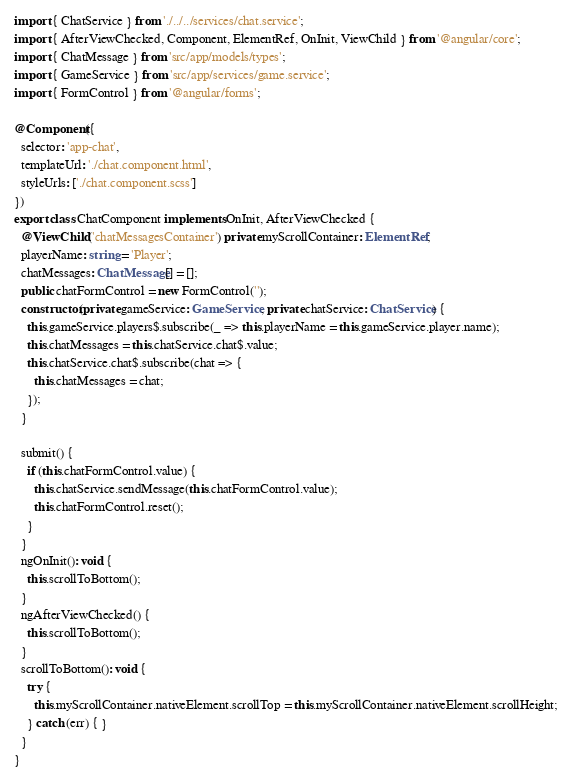Convert code to text. <code><loc_0><loc_0><loc_500><loc_500><_TypeScript_>import { ChatService } from './../../services/chat.service';
import { AfterViewChecked, Component, ElementRef, OnInit, ViewChild } from '@angular/core';
import { ChatMessage } from 'src/app/models/types';
import { GameService } from 'src/app/services/game.service';
import { FormControl } from '@angular/forms';

@Component({
  selector: 'app-chat',
  templateUrl: './chat.component.html',
  styleUrls: ['./chat.component.scss']
})
export class ChatComponent implements OnInit, AfterViewChecked {
  @ViewChild('chatMessagesContainer') private myScrollContainer: ElementRef;
  playerName: string = 'Player';
  chatMessages: ChatMessage[] = [];
  public chatFormControl = new FormControl('');
  constructor(private gameService: GameService, private chatService: ChatService) {
    this.gameService.players$.subscribe(_ => this.playerName = this.gameService.player.name);
    this.chatMessages = this.chatService.chat$.value;
    this.chatService.chat$.subscribe(chat => {
      this.chatMessages = chat;
    });
  }

  submit() {
    if (this.chatFormControl.value) {
      this.chatService.sendMessage(this.chatFormControl.value);
      this.chatFormControl.reset();
    }
  }
  ngOnInit(): void {
    this.scrollToBottom();
  }
  ngAfterViewChecked() {
    this.scrollToBottom();
  }
  scrollToBottom(): void {
    try {
      this.myScrollContainer.nativeElement.scrollTop = this.myScrollContainer.nativeElement.scrollHeight;
    } catch (err) { }
  }
}
</code> 